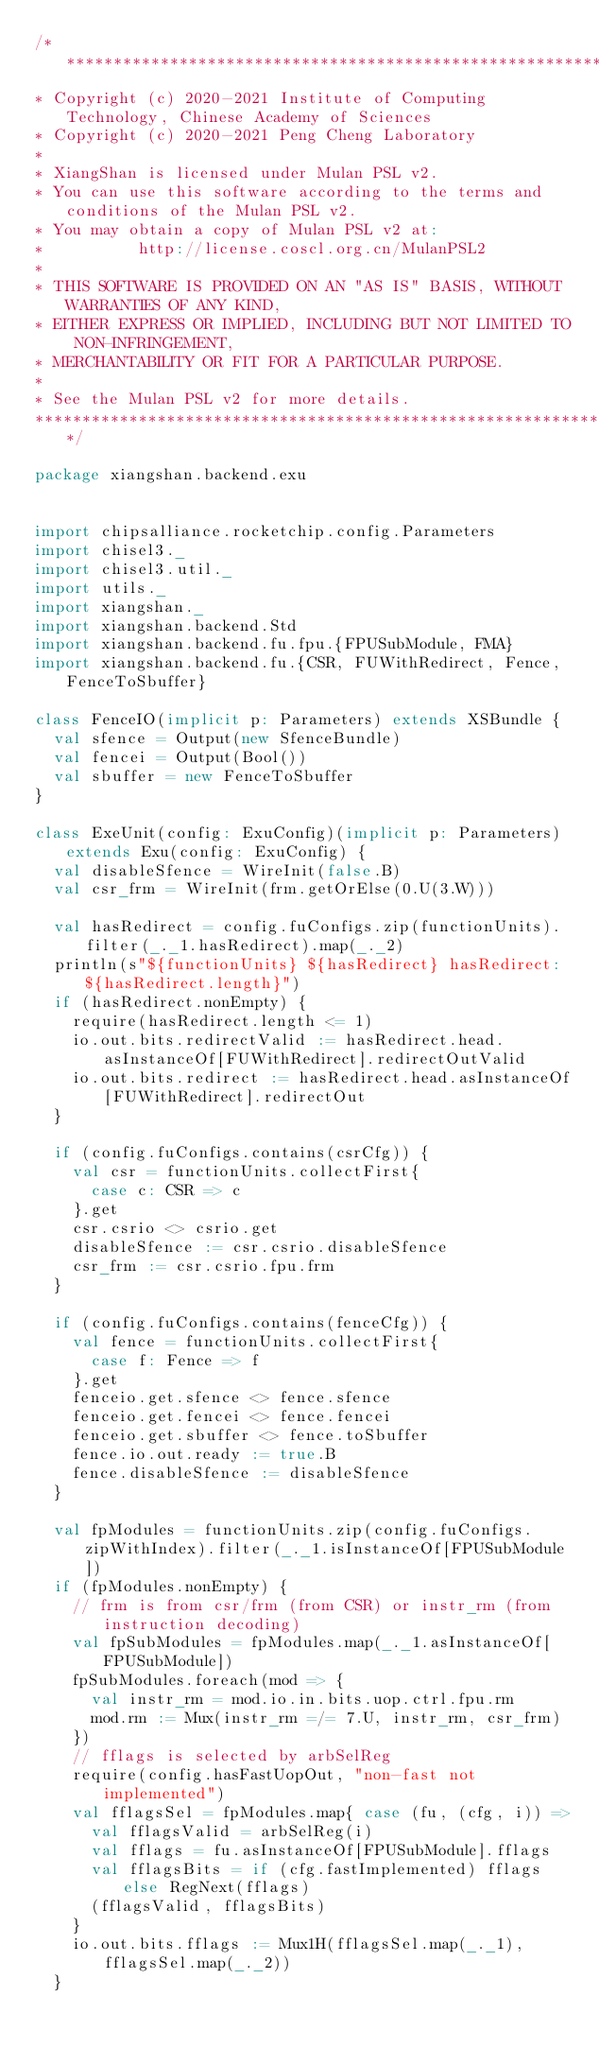Convert code to text. <code><loc_0><loc_0><loc_500><loc_500><_Scala_>/***************************************************************************************
* Copyright (c) 2020-2021 Institute of Computing Technology, Chinese Academy of Sciences
* Copyright (c) 2020-2021 Peng Cheng Laboratory
*
* XiangShan is licensed under Mulan PSL v2.
* You can use this software according to the terms and conditions of the Mulan PSL v2.
* You may obtain a copy of Mulan PSL v2 at:
*          http://license.coscl.org.cn/MulanPSL2
*
* THIS SOFTWARE IS PROVIDED ON AN "AS IS" BASIS, WITHOUT WARRANTIES OF ANY KIND,
* EITHER EXPRESS OR IMPLIED, INCLUDING BUT NOT LIMITED TO NON-INFRINGEMENT,
* MERCHANTABILITY OR FIT FOR A PARTICULAR PURPOSE.
*
* See the Mulan PSL v2 for more details.
***************************************************************************************/

package xiangshan.backend.exu


import chipsalliance.rocketchip.config.Parameters
import chisel3._
import chisel3.util._
import utils._
import xiangshan._
import xiangshan.backend.Std
import xiangshan.backend.fu.fpu.{FPUSubModule, FMA}
import xiangshan.backend.fu.{CSR, FUWithRedirect, Fence, FenceToSbuffer}

class FenceIO(implicit p: Parameters) extends XSBundle {
  val sfence = Output(new SfenceBundle)
  val fencei = Output(Bool())
  val sbuffer = new FenceToSbuffer
}

class ExeUnit(config: ExuConfig)(implicit p: Parameters) extends Exu(config: ExuConfig) {
  val disableSfence = WireInit(false.B)
  val csr_frm = WireInit(frm.getOrElse(0.U(3.W)))

  val hasRedirect = config.fuConfigs.zip(functionUnits).filter(_._1.hasRedirect).map(_._2)
  println(s"${functionUnits} ${hasRedirect} hasRedirect: ${hasRedirect.length}")
  if (hasRedirect.nonEmpty) {
    require(hasRedirect.length <= 1)
    io.out.bits.redirectValid := hasRedirect.head.asInstanceOf[FUWithRedirect].redirectOutValid
    io.out.bits.redirect := hasRedirect.head.asInstanceOf[FUWithRedirect].redirectOut
  }

  if (config.fuConfigs.contains(csrCfg)) {
    val csr = functionUnits.collectFirst{
      case c: CSR => c
    }.get
    csr.csrio <> csrio.get
    disableSfence := csr.csrio.disableSfence
    csr_frm := csr.csrio.fpu.frm
  }

  if (config.fuConfigs.contains(fenceCfg)) {
    val fence = functionUnits.collectFirst{
      case f: Fence => f
    }.get
    fenceio.get.sfence <> fence.sfence
    fenceio.get.fencei <> fence.fencei
    fenceio.get.sbuffer <> fence.toSbuffer
    fence.io.out.ready := true.B
    fence.disableSfence := disableSfence
  }

  val fpModules = functionUnits.zip(config.fuConfigs.zipWithIndex).filter(_._1.isInstanceOf[FPUSubModule])
  if (fpModules.nonEmpty) {
    // frm is from csr/frm (from CSR) or instr_rm (from instruction decoding)
    val fpSubModules = fpModules.map(_._1.asInstanceOf[FPUSubModule])
    fpSubModules.foreach(mod => {
      val instr_rm = mod.io.in.bits.uop.ctrl.fpu.rm
      mod.rm := Mux(instr_rm =/= 7.U, instr_rm, csr_frm)
    })
    // fflags is selected by arbSelReg
    require(config.hasFastUopOut, "non-fast not implemented")
    val fflagsSel = fpModules.map{ case (fu, (cfg, i)) =>
      val fflagsValid = arbSelReg(i)
      val fflags = fu.asInstanceOf[FPUSubModule].fflags
      val fflagsBits = if (cfg.fastImplemented) fflags else RegNext(fflags)
      (fflagsValid, fflagsBits)
    }
    io.out.bits.fflags := Mux1H(fflagsSel.map(_._1), fflagsSel.map(_._2))
  }
</code> 